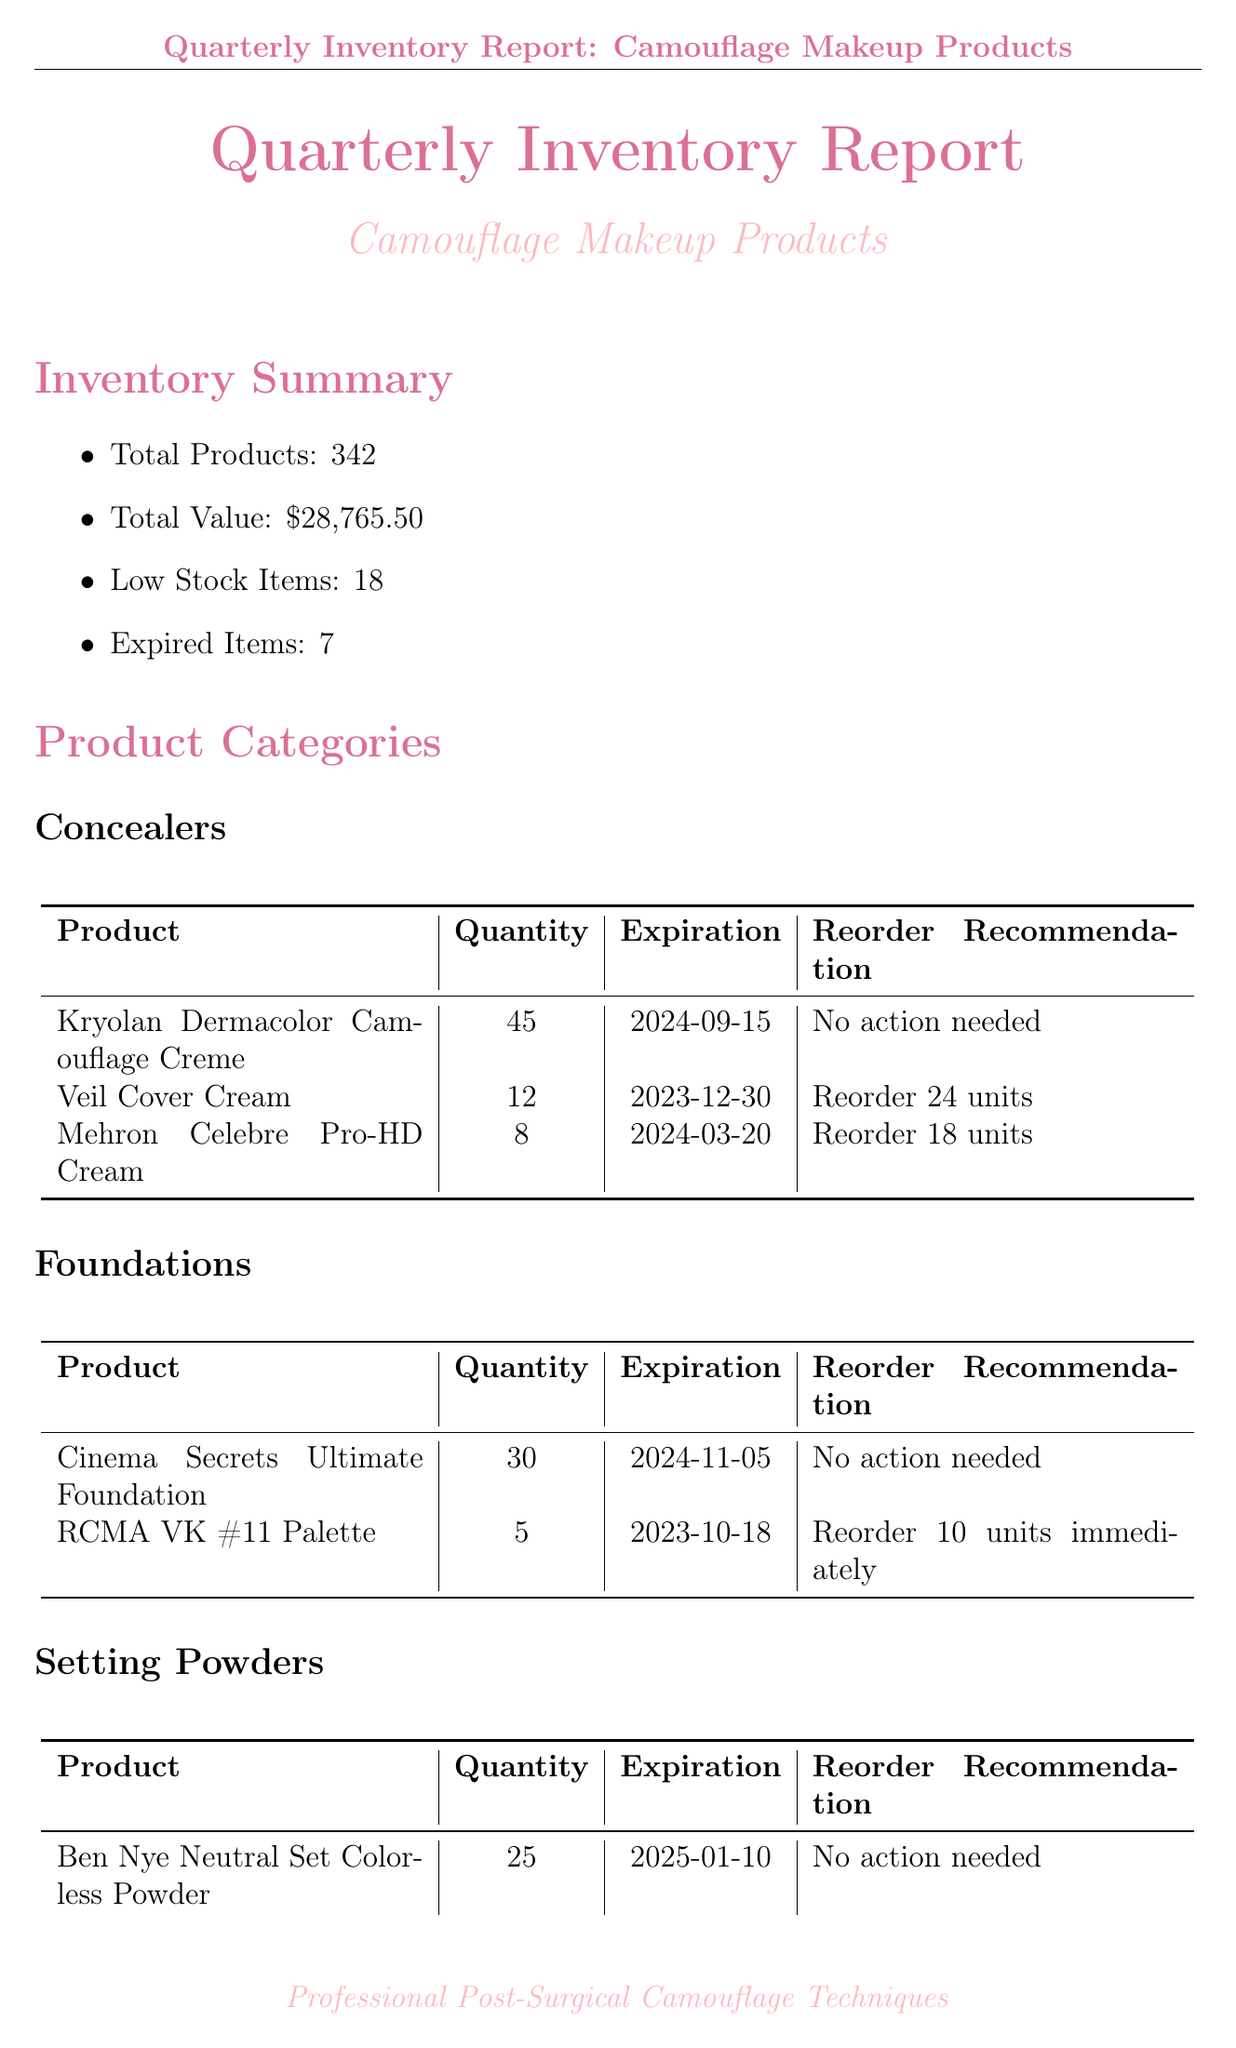What is the total number of products? The total number of products is listed in the inventory summary section of the document.
Answer: 342 How many expired items are there? The number of expired items is noted in the inventory summary section of the document.
Answer: 7 What is the reorder recommendation for the Veil Cover Cream? The reorder recommendation can be found under the concealers category in the document.
Answer: Reorder 24 units Which supplier is preferred for Kryolan products? The preferred supplier for Kryolan products is mentioned in the supplier information section.
Answer: Frends Beauty Supply What is the expiration date for the RCMA VK #11 Palette? The expiration date for this product is listed in the foundations category.
Answer: 2023-10-18 What is the quantity of the Graftobian Corrector Wheel? The quantity for this product can be found in the color correctors category.
Answer: 2 What are the storage conditions regarding temperature? The conditions are specified in the storage conditions section of the document.
Answer: 18-22°C (64-72°F) What priority level is assigned to reorder the Laura Mercier Translucent Loose Setting Powder? The priority level is stated in the reorder priorities section.
Answer: Medium Priority What was the percentage change in inventory value from the previous quarter? The percentage change is listed under the quarterly comparison section.
Answer: +6.6% 